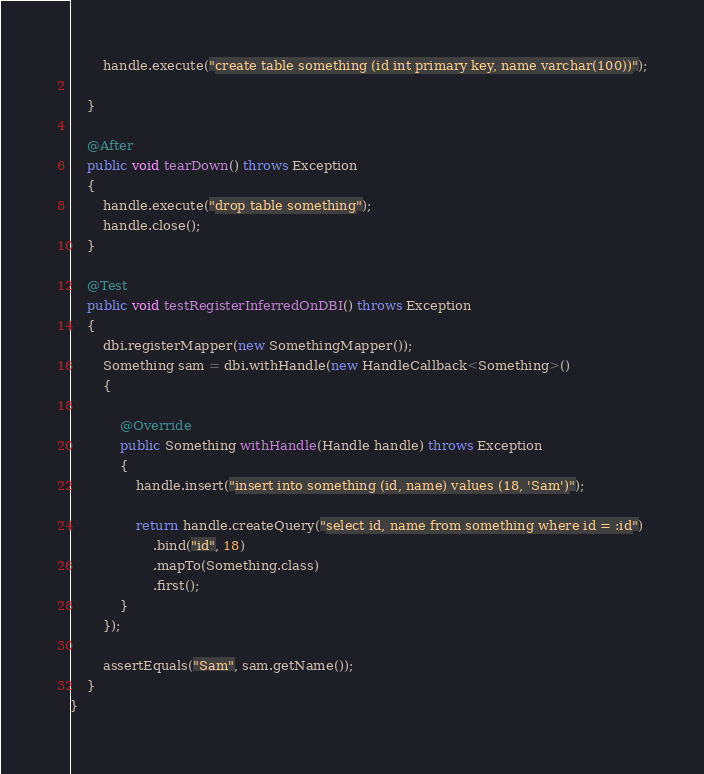Convert code to text. <code><loc_0><loc_0><loc_500><loc_500><_Java_>
        handle.execute("create table something (id int primary key, name varchar(100))");

    }

    @After
    public void tearDown() throws Exception
    {
        handle.execute("drop table something");
        handle.close();
    }

    @Test
    public void testRegisterInferredOnDBI() throws Exception
    {
        dbi.registerMapper(new SomethingMapper());
        Something sam = dbi.withHandle(new HandleCallback<Something>()
        {

            @Override
            public Something withHandle(Handle handle) throws Exception
            {
                handle.insert("insert into something (id, name) values (18, 'Sam')");

                return handle.createQuery("select id, name from something where id = :id")
                    .bind("id", 18)
                    .mapTo(Something.class)
                    .first();
            }
        });

        assertEquals("Sam", sam.getName());
    }
}
</code> 